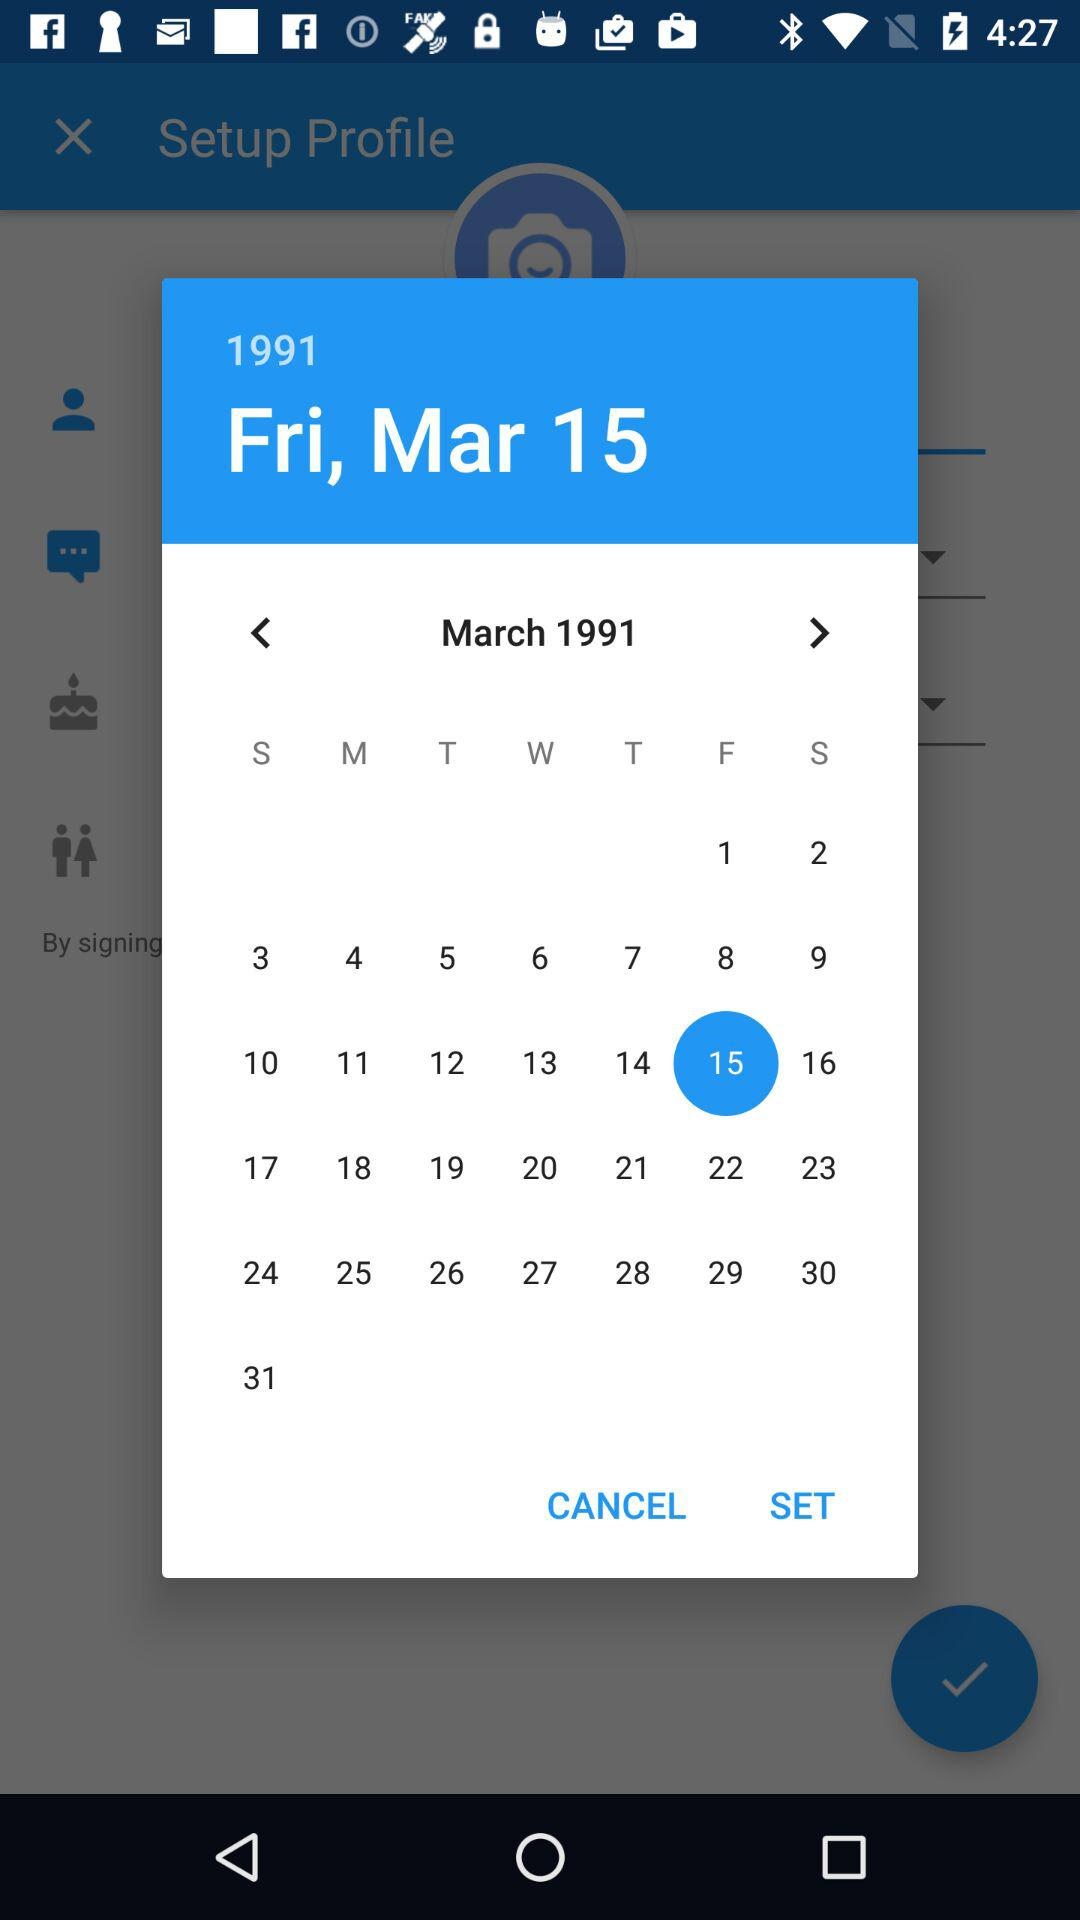What is the selected date? The selected date is Friday, March 15, 1991. 